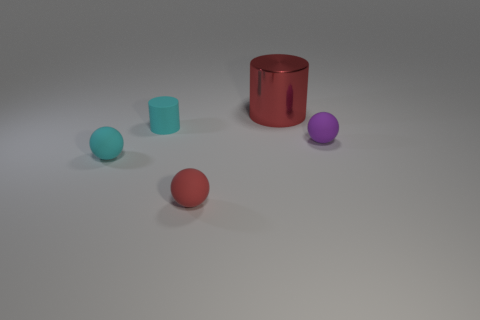Are there fewer cyan balls that are on the right side of the tiny cyan rubber ball than big red shiny cylinders in front of the small purple object?
Your response must be concise. No. Is there a small metal thing of the same shape as the large object?
Your response must be concise. No. Does the shiny thing have the same shape as the tiny purple rubber object?
Provide a short and direct response. No. What number of tiny things are either yellow things or cyan rubber spheres?
Keep it short and to the point. 1. Is the number of cyan rubber things greater than the number of gray matte cylinders?
Provide a short and direct response. Yes. The red sphere that is made of the same material as the tiny cylinder is what size?
Your answer should be very brief. Small. Do the ball that is on the right side of the metal object and the red object that is to the left of the big cylinder have the same size?
Make the answer very short. Yes. How many things are either things to the left of the red matte thing or small cyan cylinders?
Provide a short and direct response. 2. Are there fewer balls than purple rubber objects?
Your response must be concise. No. What shape is the cyan matte object behind the tiny sphere that is behind the cyan rubber thing that is in front of the small purple thing?
Provide a short and direct response. Cylinder. 